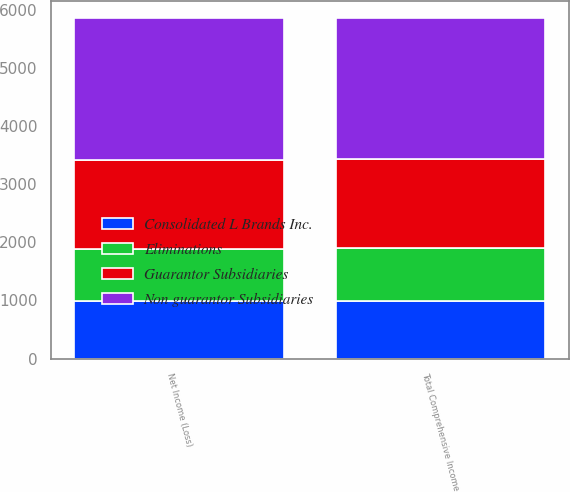Convert chart to OTSL. <chart><loc_0><loc_0><loc_500><loc_500><stacked_bar_chart><ecel><fcel>Net Income (Loss)<fcel>Total Comprehensive Income<nl><fcel>Consolidated L Brands Inc.<fcel>983<fcel>983<nl><fcel>Guarantor Subsidiaries<fcel>1523<fcel>1523<nl><fcel>Eliminations<fcel>910<fcel>922<nl><fcel>Non guarantor Subsidiaries<fcel>2433<fcel>2433<nl></chart> 